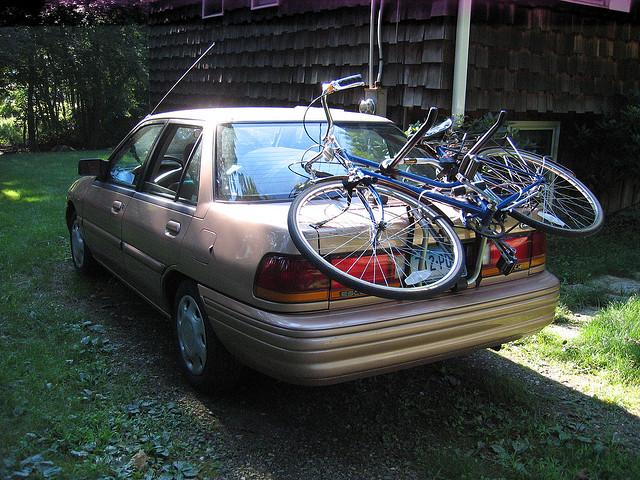What is the car parked next to?
Short answer required. House. Where is the car?
Give a very brief answer. Driveway. Is the trunk open or closed?
Write a very short answer. Closed. Is this a modern car?
Quick response, please. No. What color is the car?
Answer briefly. Gold. What is attached to the back trunk of the car?
Concise answer only. Bike. 